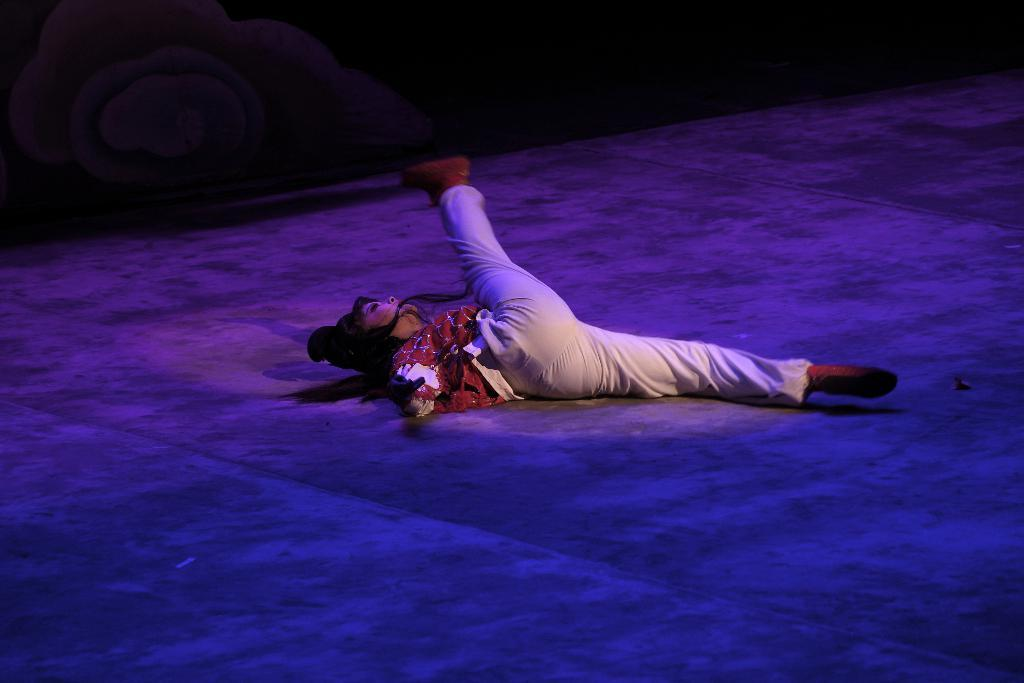What is the main subject of the image? The main subject of the image is a lady lying on the floor. Can you see any goldfish swimming in the image? There are no goldfish present in the image. What type of plants can be seen growing in the image? There is no mention of plants in the image. Is there a stove visible in the image? There is no stove present in the image. 